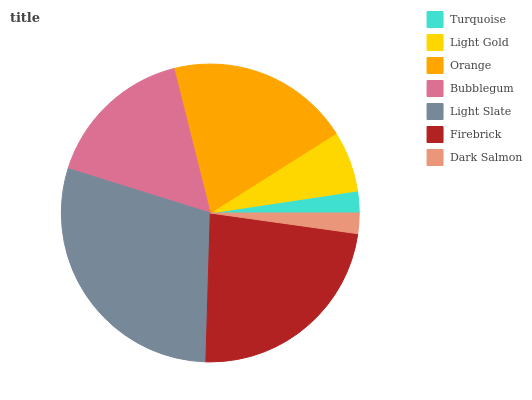Is Dark Salmon the minimum?
Answer yes or no. Yes. Is Light Slate the maximum?
Answer yes or no. Yes. Is Light Gold the minimum?
Answer yes or no. No. Is Light Gold the maximum?
Answer yes or no. No. Is Light Gold greater than Turquoise?
Answer yes or no. Yes. Is Turquoise less than Light Gold?
Answer yes or no. Yes. Is Turquoise greater than Light Gold?
Answer yes or no. No. Is Light Gold less than Turquoise?
Answer yes or no. No. Is Bubblegum the high median?
Answer yes or no. Yes. Is Bubblegum the low median?
Answer yes or no. Yes. Is Light Gold the high median?
Answer yes or no. No. Is Firebrick the low median?
Answer yes or no. No. 